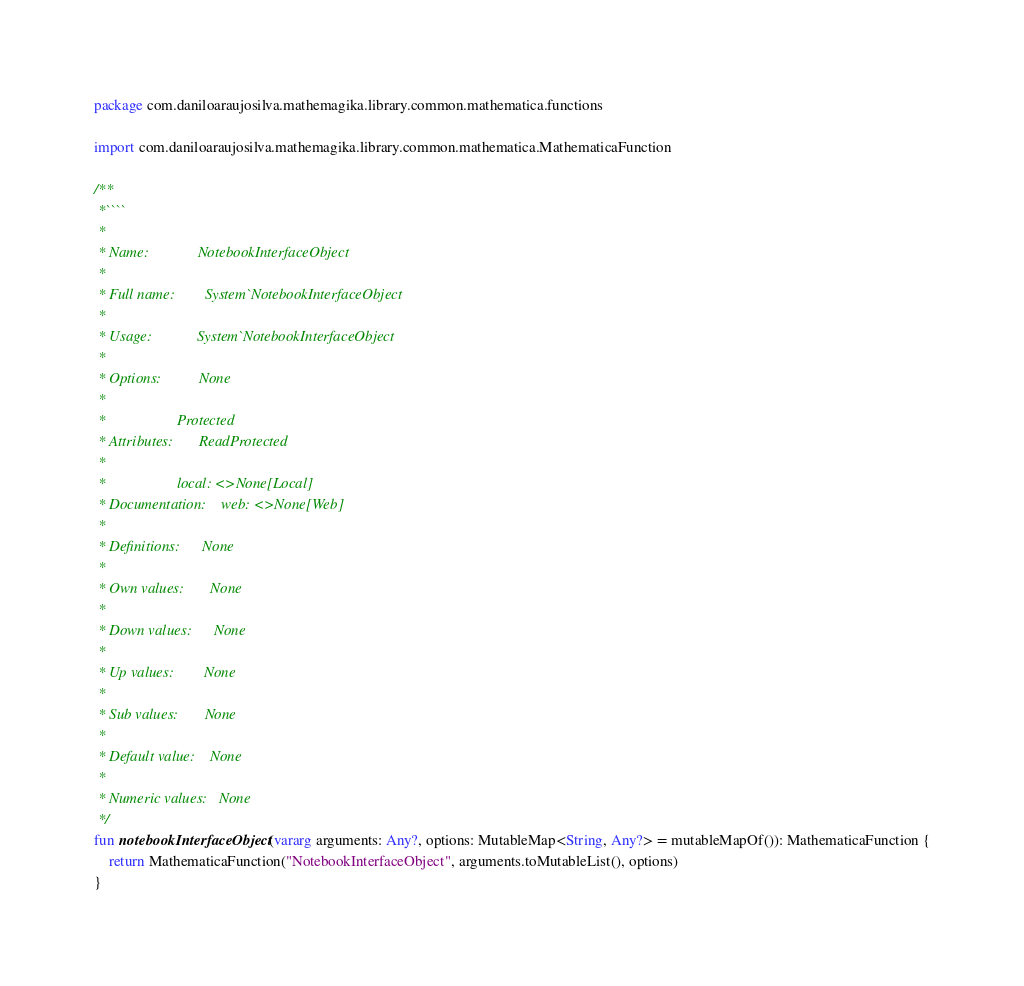Convert code to text. <code><loc_0><loc_0><loc_500><loc_500><_Kotlin_>package com.daniloaraujosilva.mathemagika.library.common.mathematica.functions

import com.daniloaraujosilva.mathemagika.library.common.mathematica.MathematicaFunction

/**
 *````
 *
 * Name:             NotebookInterfaceObject
 *
 * Full name:        System`NotebookInterfaceObject
 *
 * Usage:            System`NotebookInterfaceObject
 *
 * Options:          None
 *
 *                   Protected
 * Attributes:       ReadProtected
 *
 *                   local: <>None[Local]
 * Documentation:    web: <>None[Web]
 *
 * Definitions:      None
 *
 * Own values:       None
 *
 * Down values:      None
 *
 * Up values:        None
 *
 * Sub values:       None
 *
 * Default value:    None
 *
 * Numeric values:   None
 */
fun notebookInterfaceObject(vararg arguments: Any?, options: MutableMap<String, Any?> = mutableMapOf()): MathematicaFunction {
	return MathematicaFunction("NotebookInterfaceObject", arguments.toMutableList(), options)
}
</code> 